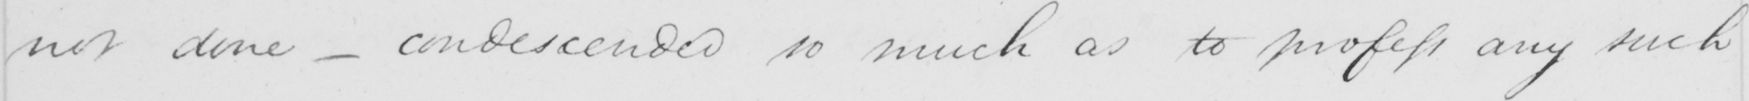Please provide the text content of this handwritten line. not done  _  condescended so much as to profess any such 